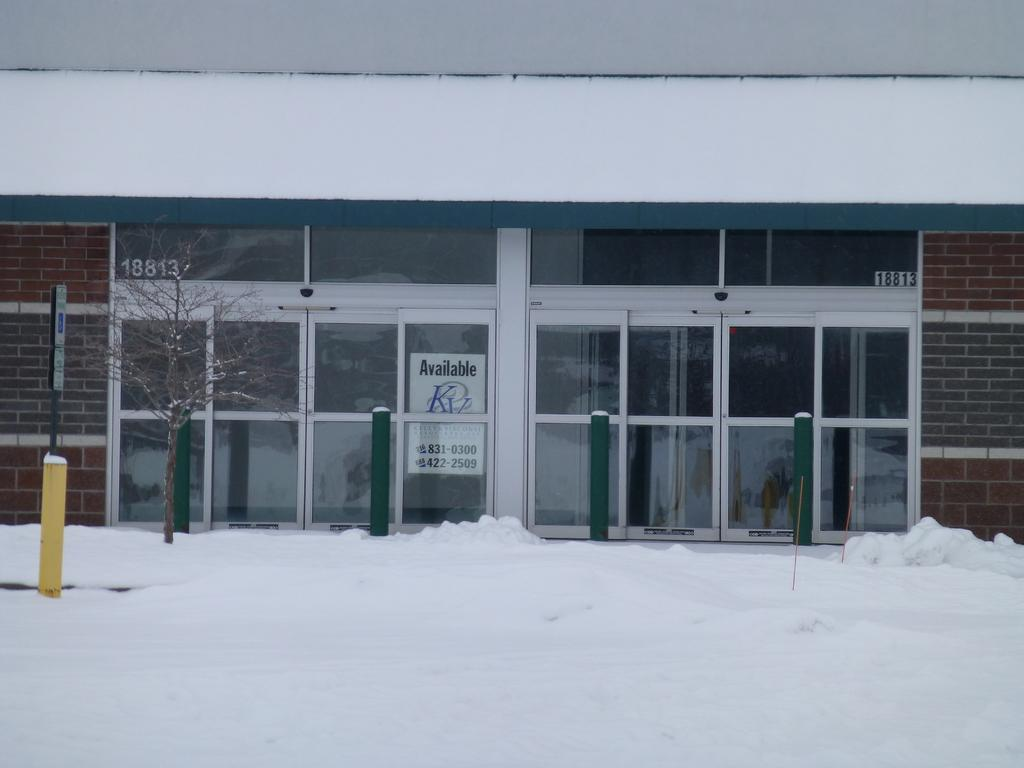What type of structure can be seen in the image? There is an entrance in the image. What materials were used to construct the entrance? The entrance is made with glass and brick walls. What is the surrounding environment of the entrance? The entrance is surrounded by ice. How do the brothers contribute to the growth of the branch in the image? There are no brothers or branches present in the image. 